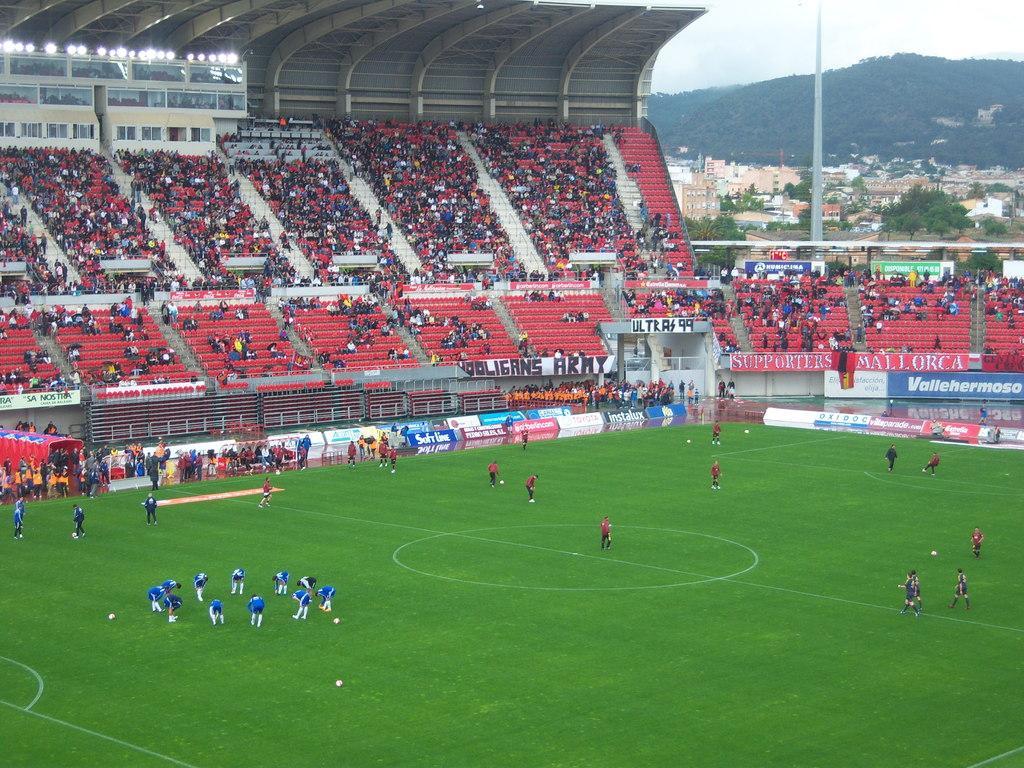Describe this image in one or two sentences. There are people on the green surface and these people are doing warm up. These are audience and we can see stadium. In the background we can see pole,buildings,trees and sky. 